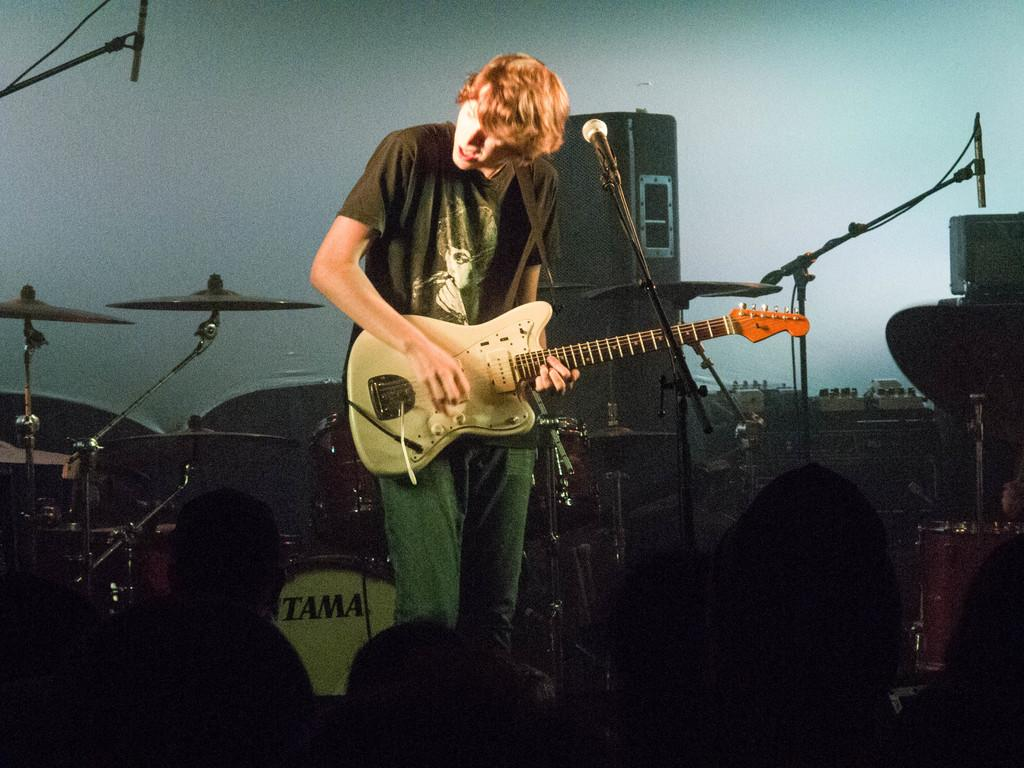What is the man in the image doing? The man is playing a guitar in the image. What is the man near while playing the guitar? The man is near a microphone in the image. What musical instruments can be seen in the background of the image? There are drums, speakers, a crash cymbal, and a cymbal stand in the background of the image. Who else is present in the image besides the man playing the guitar? There is a group of people in the background of the image. What type of structure is visible in the background of the image? There is a wall in the background of the image. What type of industry can be seen in the image? There is no industry present in the image; it features a man playing a guitar and musical instruments in the background. What type of carriage is being used by the man in the image? There is no carriage present in the image; the man is standing and playing a guitar. 